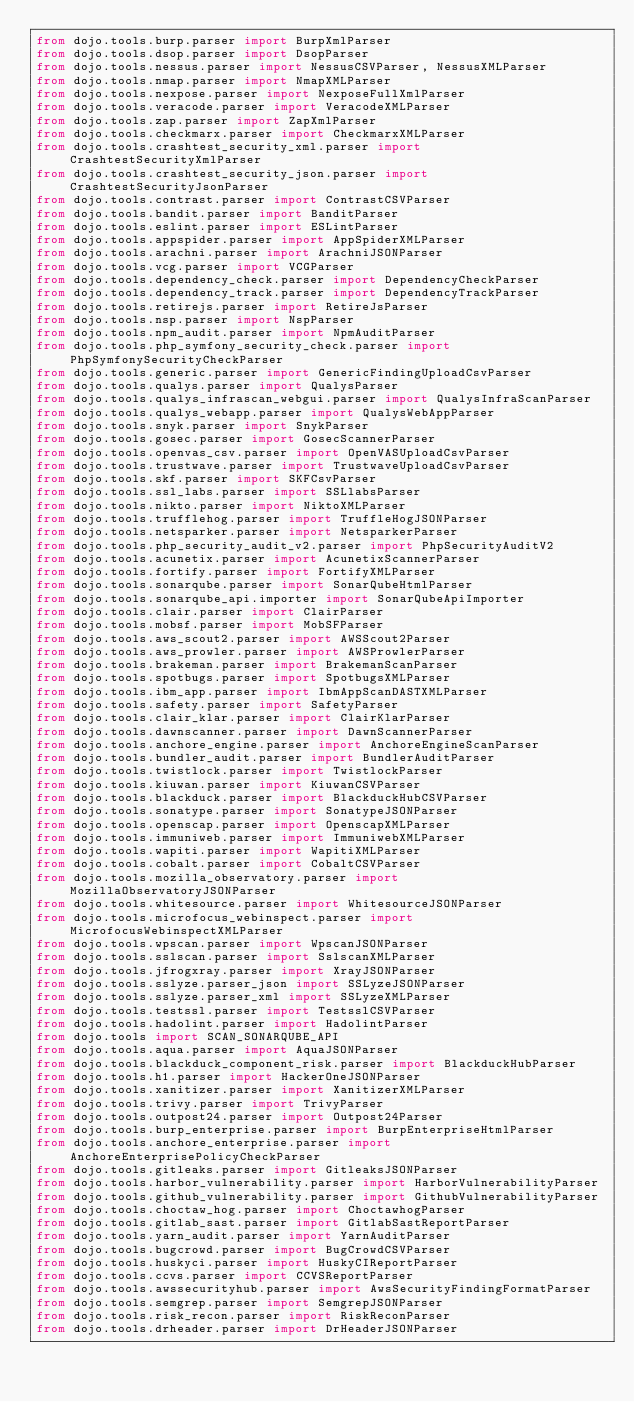<code> <loc_0><loc_0><loc_500><loc_500><_Python_>from dojo.tools.burp.parser import BurpXmlParser
from dojo.tools.dsop.parser import DsopParser
from dojo.tools.nessus.parser import NessusCSVParser, NessusXMLParser
from dojo.tools.nmap.parser import NmapXMLParser
from dojo.tools.nexpose.parser import NexposeFullXmlParser
from dojo.tools.veracode.parser import VeracodeXMLParser
from dojo.tools.zap.parser import ZapXmlParser
from dojo.tools.checkmarx.parser import CheckmarxXMLParser
from dojo.tools.crashtest_security_xml.parser import CrashtestSecurityXmlParser
from dojo.tools.crashtest_security_json.parser import CrashtestSecurityJsonParser
from dojo.tools.contrast.parser import ContrastCSVParser
from dojo.tools.bandit.parser import BanditParser
from dojo.tools.eslint.parser import ESLintParser
from dojo.tools.appspider.parser import AppSpiderXMLParser
from dojo.tools.arachni.parser import ArachniJSONParser
from dojo.tools.vcg.parser import VCGParser
from dojo.tools.dependency_check.parser import DependencyCheckParser
from dojo.tools.dependency_track.parser import DependencyTrackParser
from dojo.tools.retirejs.parser import RetireJsParser
from dojo.tools.nsp.parser import NspParser
from dojo.tools.npm_audit.parser import NpmAuditParser
from dojo.tools.php_symfony_security_check.parser import PhpSymfonySecurityCheckParser
from dojo.tools.generic.parser import GenericFindingUploadCsvParser
from dojo.tools.qualys.parser import QualysParser
from dojo.tools.qualys_infrascan_webgui.parser import QualysInfraScanParser
from dojo.tools.qualys_webapp.parser import QualysWebAppParser
from dojo.tools.snyk.parser import SnykParser
from dojo.tools.gosec.parser import GosecScannerParser
from dojo.tools.openvas_csv.parser import OpenVASUploadCsvParser
from dojo.tools.trustwave.parser import TrustwaveUploadCsvParser
from dojo.tools.skf.parser import SKFCsvParser
from dojo.tools.ssl_labs.parser import SSLlabsParser
from dojo.tools.nikto.parser import NiktoXMLParser
from dojo.tools.trufflehog.parser import TruffleHogJSONParser
from dojo.tools.netsparker.parser import NetsparkerParser
from dojo.tools.php_security_audit_v2.parser import PhpSecurityAuditV2
from dojo.tools.acunetix.parser import AcunetixScannerParser
from dojo.tools.fortify.parser import FortifyXMLParser
from dojo.tools.sonarqube.parser import SonarQubeHtmlParser
from dojo.tools.sonarqube_api.importer import SonarQubeApiImporter
from dojo.tools.clair.parser import ClairParser
from dojo.tools.mobsf.parser import MobSFParser
from dojo.tools.aws_scout2.parser import AWSScout2Parser
from dojo.tools.aws_prowler.parser import AWSProwlerParser
from dojo.tools.brakeman.parser import BrakemanScanParser
from dojo.tools.spotbugs.parser import SpotbugsXMLParser
from dojo.tools.ibm_app.parser import IbmAppScanDASTXMLParser
from dojo.tools.safety.parser import SafetyParser
from dojo.tools.clair_klar.parser import ClairKlarParser
from dojo.tools.dawnscanner.parser import DawnScannerParser
from dojo.tools.anchore_engine.parser import AnchoreEngineScanParser
from dojo.tools.bundler_audit.parser import BundlerAuditParser
from dojo.tools.twistlock.parser import TwistlockParser
from dojo.tools.kiuwan.parser import KiuwanCSVParser
from dojo.tools.blackduck.parser import BlackduckHubCSVParser
from dojo.tools.sonatype.parser import SonatypeJSONParser
from dojo.tools.openscap.parser import OpenscapXMLParser
from dojo.tools.immuniweb.parser import ImmuniwebXMLParser
from dojo.tools.wapiti.parser import WapitiXMLParser
from dojo.tools.cobalt.parser import CobaltCSVParser
from dojo.tools.mozilla_observatory.parser import MozillaObservatoryJSONParser
from dojo.tools.whitesource.parser import WhitesourceJSONParser
from dojo.tools.microfocus_webinspect.parser import MicrofocusWebinspectXMLParser
from dojo.tools.wpscan.parser import WpscanJSONParser
from dojo.tools.sslscan.parser import SslscanXMLParser
from dojo.tools.jfrogxray.parser import XrayJSONParser
from dojo.tools.sslyze.parser_json import SSLyzeJSONParser
from dojo.tools.sslyze.parser_xml import SSLyzeXMLParser
from dojo.tools.testssl.parser import TestsslCSVParser
from dojo.tools.hadolint.parser import HadolintParser
from dojo.tools import SCAN_SONARQUBE_API
from dojo.tools.aqua.parser import AquaJSONParser
from dojo.tools.blackduck_component_risk.parser import BlackduckHubParser
from dojo.tools.h1.parser import HackerOneJSONParser
from dojo.tools.xanitizer.parser import XanitizerXMLParser
from dojo.tools.trivy.parser import TrivyParser
from dojo.tools.outpost24.parser import Outpost24Parser
from dojo.tools.burp_enterprise.parser import BurpEnterpriseHtmlParser
from dojo.tools.anchore_enterprise.parser import AnchoreEnterprisePolicyCheckParser
from dojo.tools.gitleaks.parser import GitleaksJSONParser
from dojo.tools.harbor_vulnerability.parser import HarborVulnerabilityParser
from dojo.tools.github_vulnerability.parser import GithubVulnerabilityParser
from dojo.tools.choctaw_hog.parser import ChoctawhogParser
from dojo.tools.gitlab_sast.parser import GitlabSastReportParser
from dojo.tools.yarn_audit.parser import YarnAuditParser
from dojo.tools.bugcrowd.parser import BugCrowdCSVParser
from dojo.tools.huskyci.parser import HuskyCIReportParser
from dojo.tools.ccvs.parser import CCVSReportParser
from dojo.tools.awssecurityhub.parser import AwsSecurityFindingFormatParser
from dojo.tools.semgrep.parser import SemgrepJSONParser
from dojo.tools.risk_recon.parser import RiskReconParser
from dojo.tools.drheader.parser import DrHeaderJSONParser</code> 